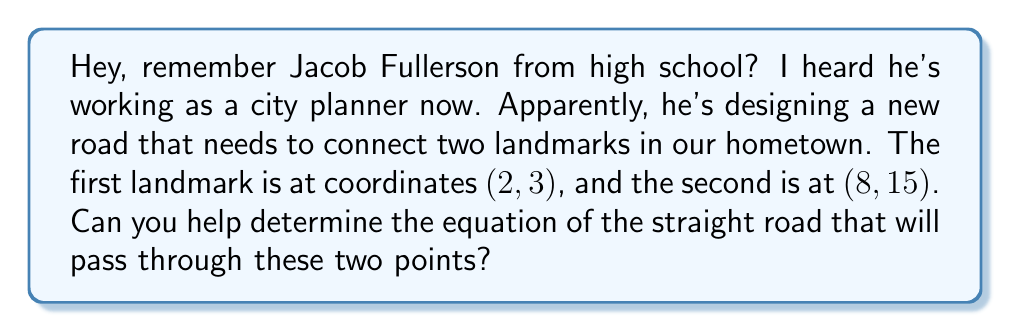Can you solve this math problem? To find the equation of a line passing through two points, we can use the point-slope form of a line. Let's approach this step-by-step:

1. First, we need to calculate the slope of the line. The slope formula is:

   $$ m = \frac{y_2 - y_1}{x_2 - x_1} $$

   Where $(x_1, y_1)$ is the first point and $(x_2, y_2)$ is the second point.

2. Plugging in our values:

   $$ m = \frac{15 - 3}{8 - 2} = \frac{12}{6} = 2 $$

3. Now that we have the slope, we can use the point-slope form of a line:

   $$ y - y_1 = m(x - x_1) $$

   We can use either of the given points. Let's use (2, 3).

4. Substituting our values:

   $$ y - 3 = 2(x - 2) $$

5. To get the equation into slope-intercept form $(y = mx + b)$, we expand the right side:

   $$ y - 3 = 2x - 4 $$

6. Add 3 to both sides:

   $$ y = 2x - 4 + 3 $$
   $$ y = 2x - 1 $$

This is the equation of the line in slope-intercept form.
Answer: $$ y = 2x - 1 $$ 